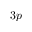<formula> <loc_0><loc_0><loc_500><loc_500>3 p</formula> 